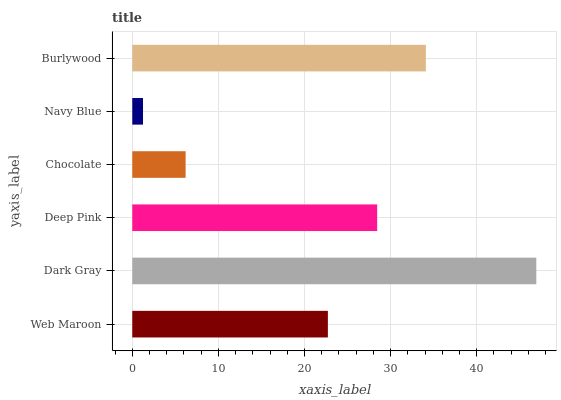Is Navy Blue the minimum?
Answer yes or no. Yes. Is Dark Gray the maximum?
Answer yes or no. Yes. Is Deep Pink the minimum?
Answer yes or no. No. Is Deep Pink the maximum?
Answer yes or no. No. Is Dark Gray greater than Deep Pink?
Answer yes or no. Yes. Is Deep Pink less than Dark Gray?
Answer yes or no. Yes. Is Deep Pink greater than Dark Gray?
Answer yes or no. No. Is Dark Gray less than Deep Pink?
Answer yes or no. No. Is Deep Pink the high median?
Answer yes or no. Yes. Is Web Maroon the low median?
Answer yes or no. Yes. Is Burlywood the high median?
Answer yes or no. No. Is Chocolate the low median?
Answer yes or no. No. 